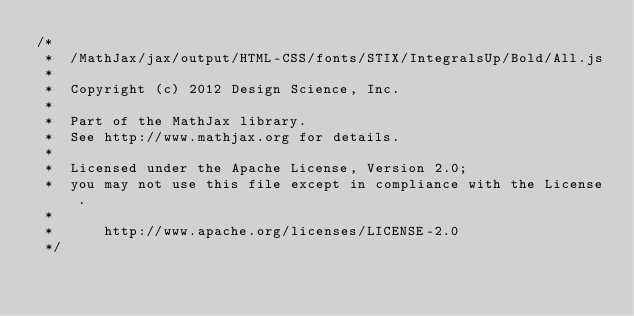<code> <loc_0><loc_0><loc_500><loc_500><_JavaScript_>/*
 *  /MathJax/jax/output/HTML-CSS/fonts/STIX/IntegralsUp/Bold/All.js
 *  
 *  Copyright (c) 2012 Design Science, Inc.
 *
 *  Part of the MathJax library.
 *  See http://www.mathjax.org for details.
 * 
 *  Licensed under the Apache License, Version 2.0;
 *  you may not use this file except in compliance with the License.
 *
 *      http://www.apache.org/licenses/LICENSE-2.0
 */
</code> 